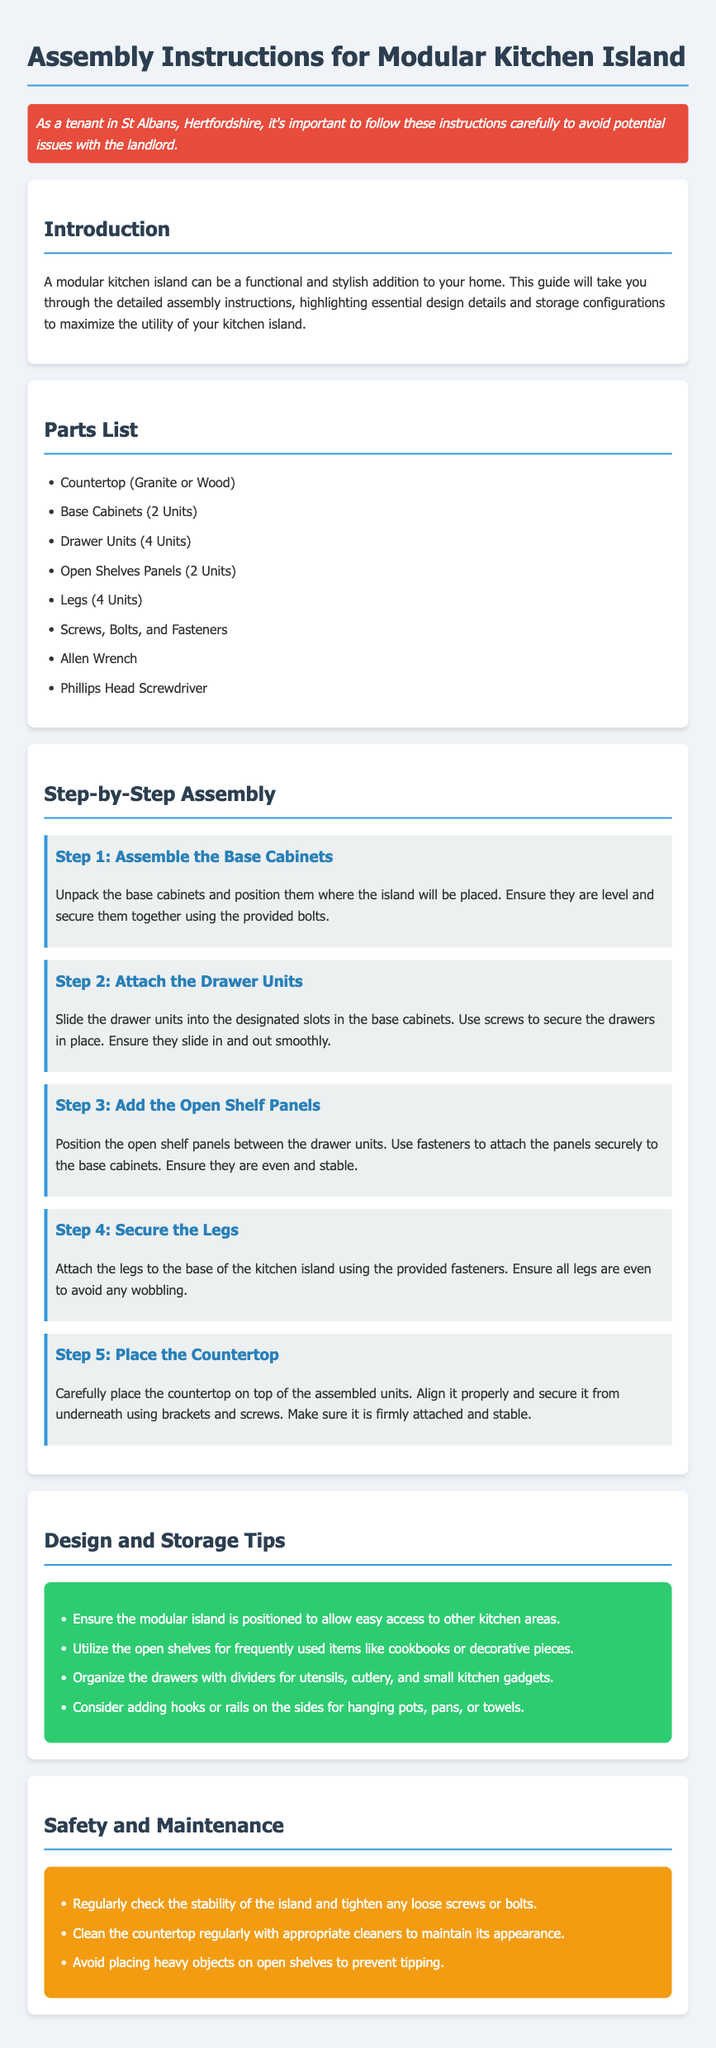What is the total number of drawer units? The document lists that there are four drawer units provided in the parts list.
Answer: 4 Units What type of screws are used to secure the legs? While the specific type of screws isn't mentioned, "provided fasteners" implies that the necessary components are included.
Answer: Fasteners What are the two types of materials recommended for the countertop? The instructions mention two materials that can be used for the countertop: Granite or Wood.
Answer: Granite or Wood In which step do you attach the drawer units? The second step explicitly details the process of sliding the drawer units into their designated spots for assembly.
Answer: Step 2 What is one design tip provided for the modular kitchen island? The document lists a design tip about the positioning of the island for easy access to other kitchen areas.
Answer: Easy access How many open shelf panels are included in the parts list? The parts list specifies that two open shelf panels are included for assembly.
Answer: 2 Units What color is the safety background in the document? The safety section is highlighted with a distinctive background color that is orange, as described in the styling section.
Answer: Orange What should you avoid placing on the open shelves? The safety advice specifically warns against placing heavy objects on the open shelves to prevent potential accidents.
Answer: Heavy objects 